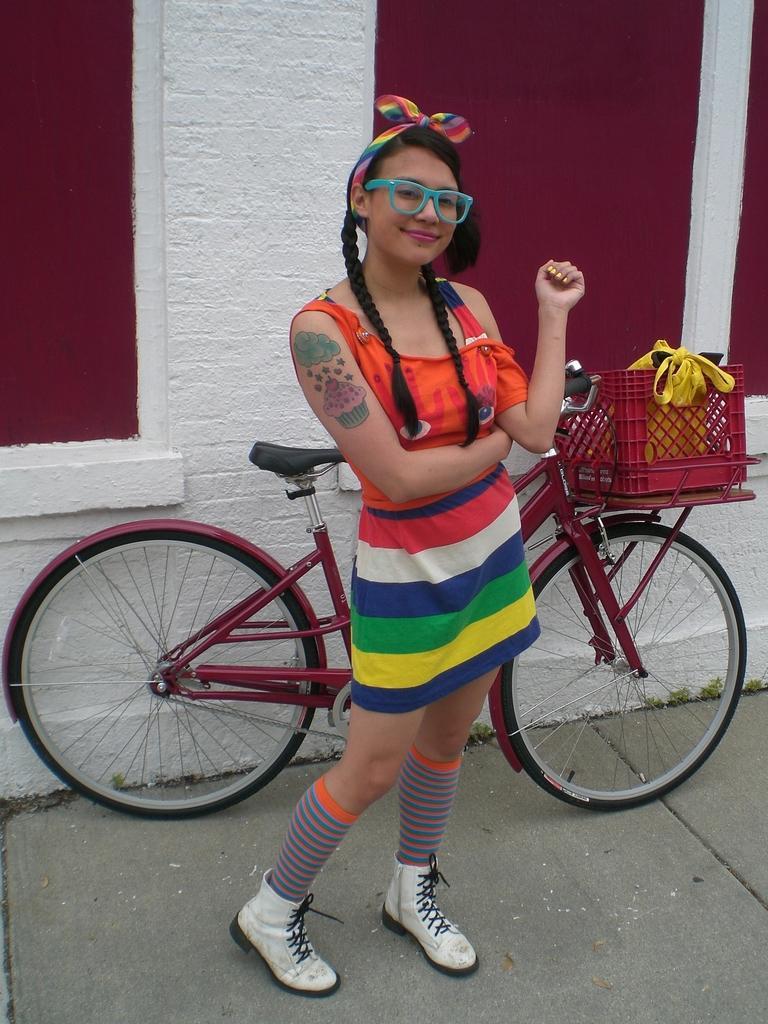Please provide a concise description of this image. Here we can see a woman is standing on the floor and behind her there is a bicycle at the wall. There is a box with some objects in it on the bicycle. 